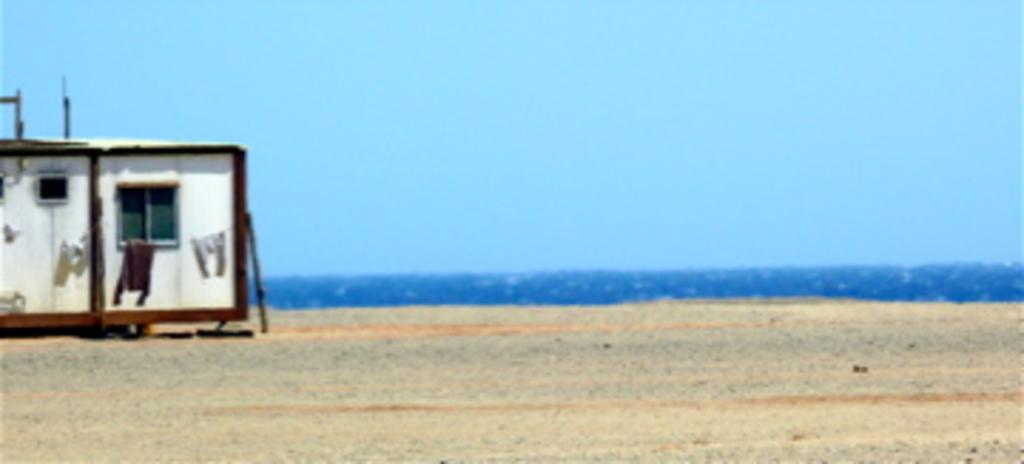Can you describe this image briefly? This image is clicked near the ocean. At the bottom, there is sand. On the left, we can see a cabin along with the window. At the top, there is the sky. 